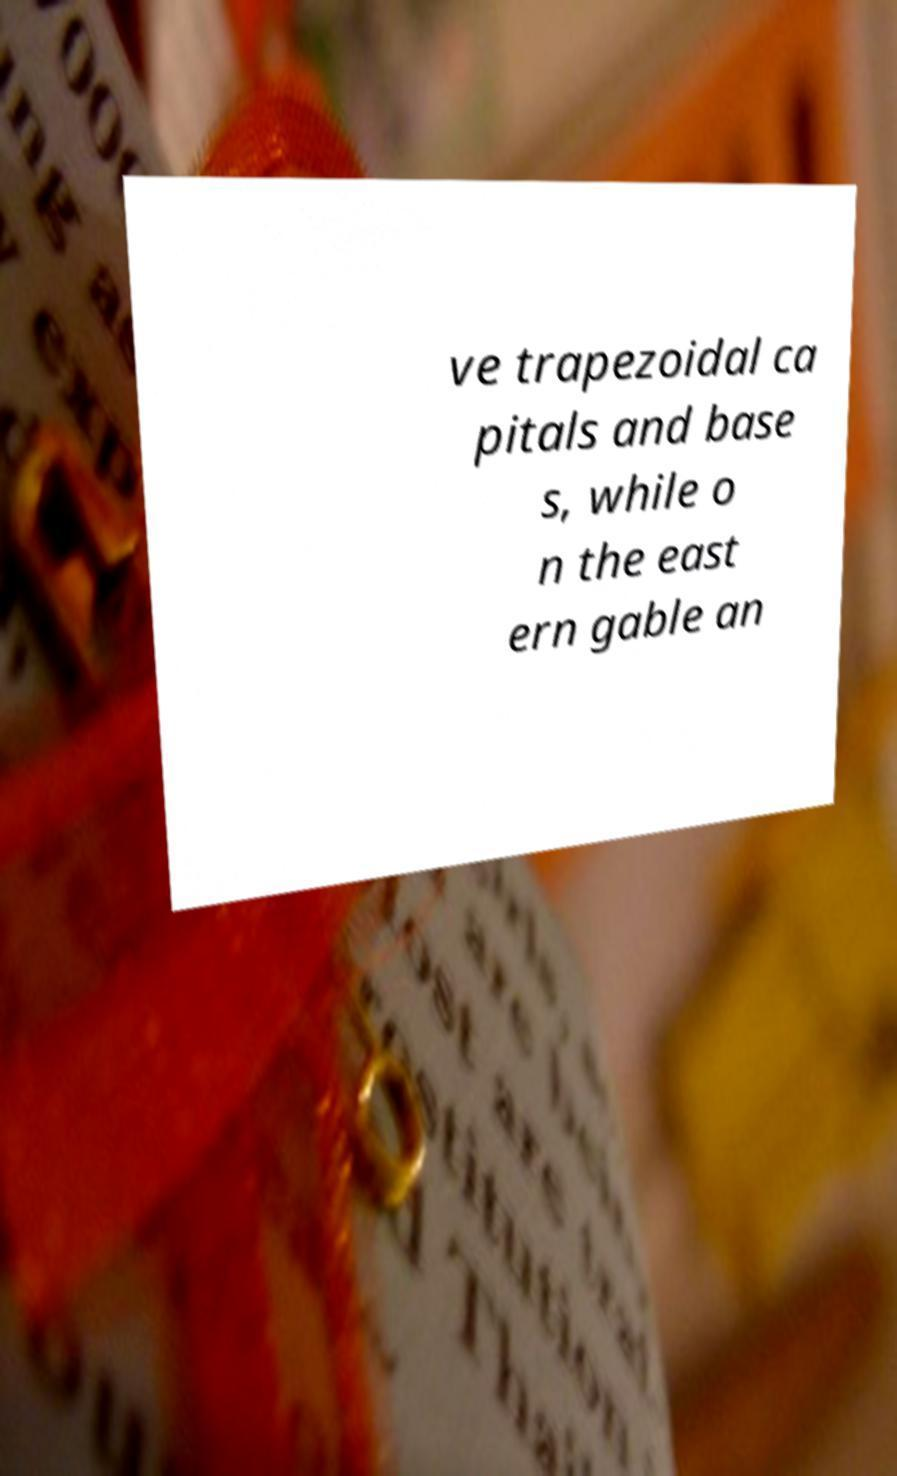Can you read and provide the text displayed in the image?This photo seems to have some interesting text. Can you extract and type it out for me? ve trapezoidal ca pitals and base s, while o n the east ern gable an 